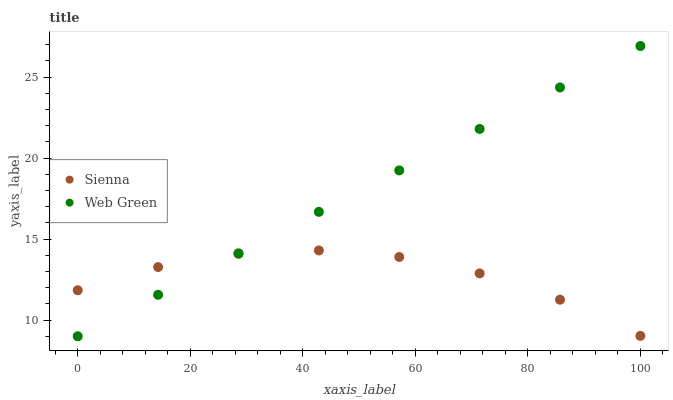Does Sienna have the minimum area under the curve?
Answer yes or no. Yes. Does Web Green have the maximum area under the curve?
Answer yes or no. Yes. Does Web Green have the minimum area under the curve?
Answer yes or no. No. Is Web Green the smoothest?
Answer yes or no. Yes. Is Sienna the roughest?
Answer yes or no. Yes. Is Web Green the roughest?
Answer yes or no. No. Does Web Green have the lowest value?
Answer yes or no. Yes. Does Web Green have the highest value?
Answer yes or no. Yes. Does Web Green intersect Sienna?
Answer yes or no. Yes. Is Web Green less than Sienna?
Answer yes or no. No. Is Web Green greater than Sienna?
Answer yes or no. No. 